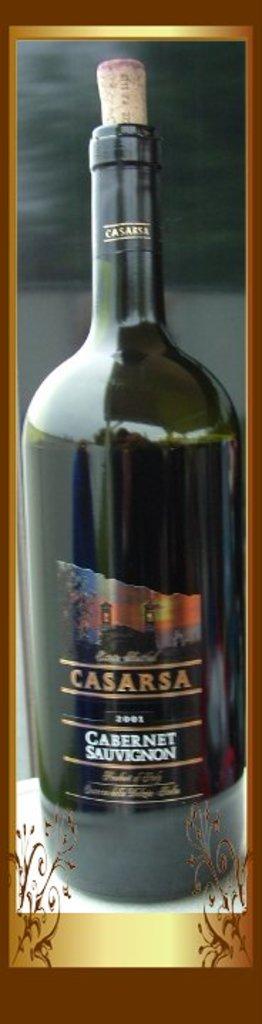What type of wine is in the bottle?
Your answer should be compact. Cabernet sauvignon. What is the brand name?
Offer a very short reply. Casarsa. 